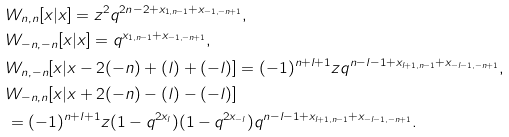<formula> <loc_0><loc_0><loc_500><loc_500>& W _ { n , n } [ x | x ] = z ^ { 2 } q ^ { 2 n - 2 + x _ { 1 , n - 1 } + x _ { - 1 , - n + 1 } } , \\ & W _ { - n , - n } [ x | x ] = q ^ { x _ { 1 , n - 1 } + x _ { - 1 , - n + 1 } } , \\ & W _ { n , - n } [ x | x - 2 ( - n ) + ( l ) + ( - l ) ] = ( - 1 ) ^ { n + l + 1 } z q ^ { n - l - 1 + x _ { l + 1 , n - 1 } + x _ { - l - 1 , - n + 1 } } , \\ & W _ { - n , n } [ x | x + 2 ( - n ) - ( l ) - ( - l ) ] \\ & = ( - 1 ) ^ { n + l + 1 } z ( 1 - q ^ { 2 x _ { l } } ) ( 1 - q ^ { 2 x _ { - l } } ) q ^ { n - l - 1 + x _ { l + 1 , n - 1 } + x _ { - l - 1 , - n + 1 } } .</formula> 